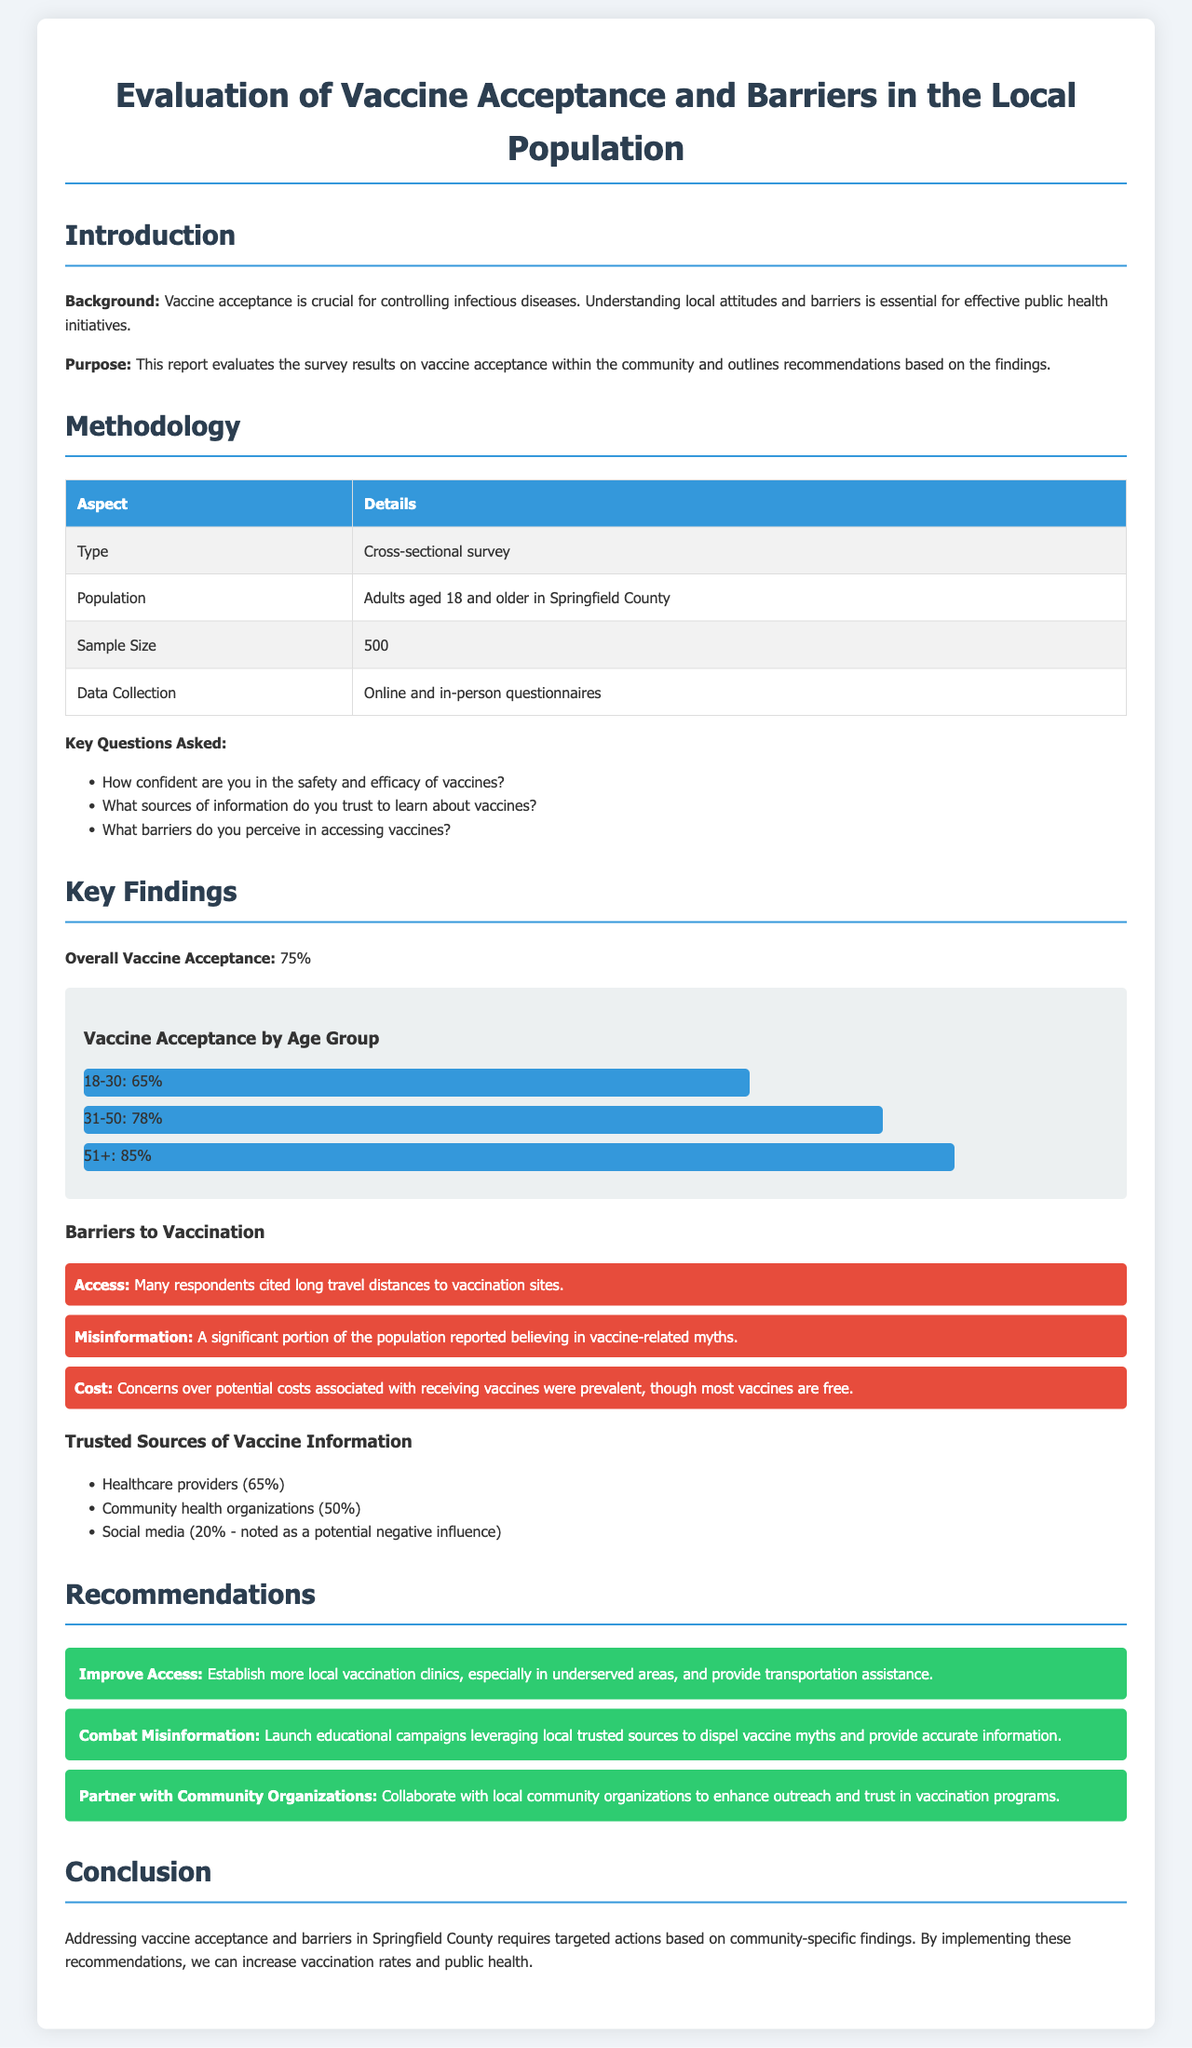what was the overall vaccine acceptance percentage? The overall vaccine acceptance percentage is explicitly stated in the document under the key findings section.
Answer: 75% how many adults were surveyed in Springfield County? The sample size of the cross-sectional survey conducted is mentioned in the methodology section.
Answer: 500 what is one major barrier to vaccination mentioned in the report? The report lists several barriers to vaccination in the findings section.
Answer: Access which age group had the highest vaccine acceptance? The document provides a comparison of vaccine acceptance rates by age group in the findings section.
Answer: 51+ what percentage of respondents trust healthcare providers for vaccine information? The percentage of respondents who trust different sources for vaccine information is given in the findings section.
Answer: 65% what recommendation is made to improve access to vaccines? The document outlines recommendations based on the survey results, focusing on improving access to vaccines.
Answer: Establish more local vaccination clinics what alternative source of vaccine information was noted as a potential negative influence? The report details trusted sources for vaccine information, including one that has a negative connotation.
Answer: Social media which group is suggested to partner with for enhancing outreach on vaccinations? The recommendations section specifically mentions groups to collaborate with for better outreach regarding vaccinations.
Answer: Community organizations 